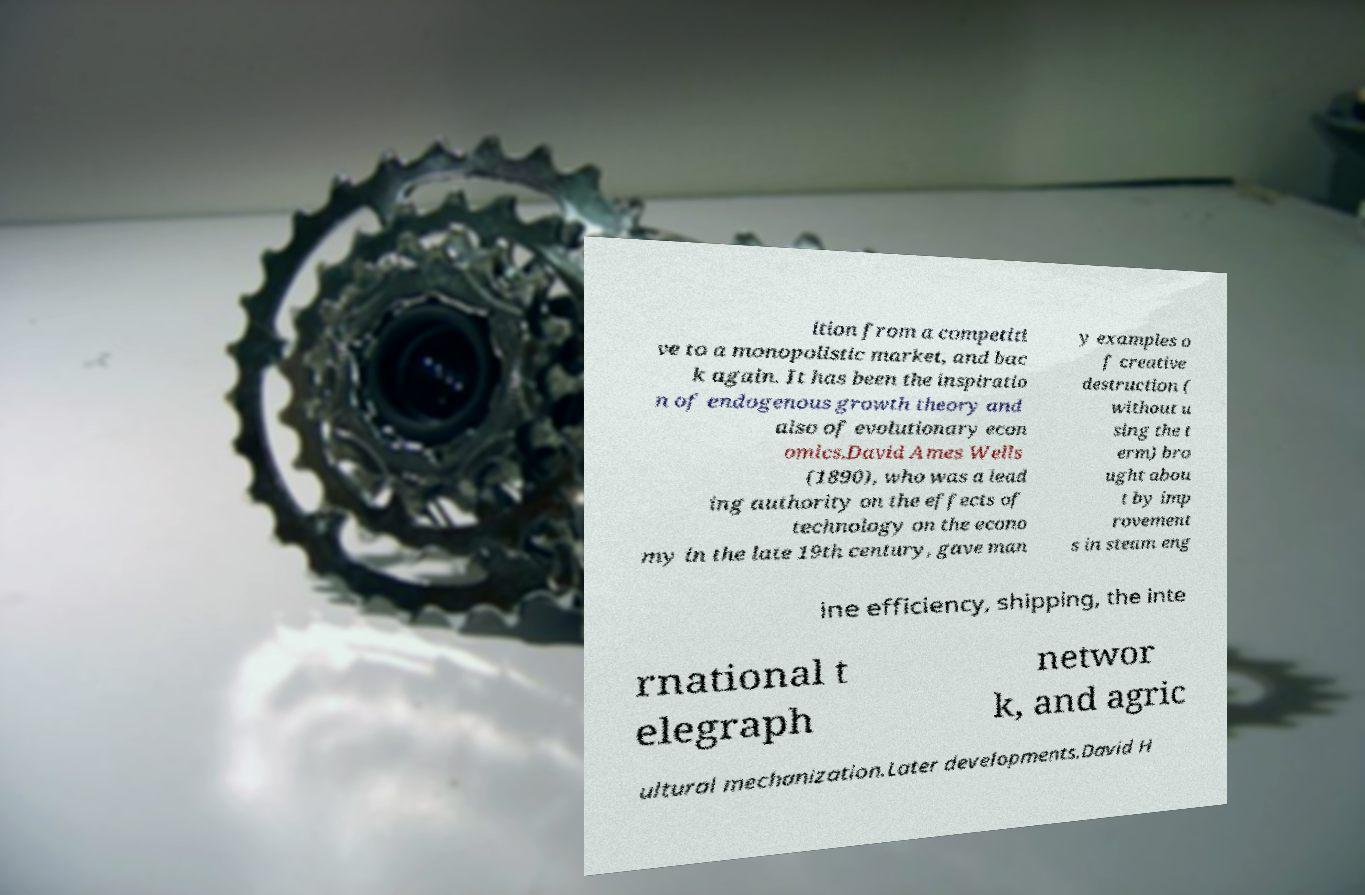For documentation purposes, I need the text within this image transcribed. Could you provide that? ition from a competiti ve to a monopolistic market, and bac k again. It has been the inspiratio n of endogenous growth theory and also of evolutionary econ omics.David Ames Wells (1890), who was a lead ing authority on the effects of technology on the econo my in the late 19th century, gave man y examples o f creative destruction ( without u sing the t erm) bro ught abou t by imp rovement s in steam eng ine efficiency, shipping, the inte rnational t elegraph networ k, and agric ultural mechanization.Later developments.David H 